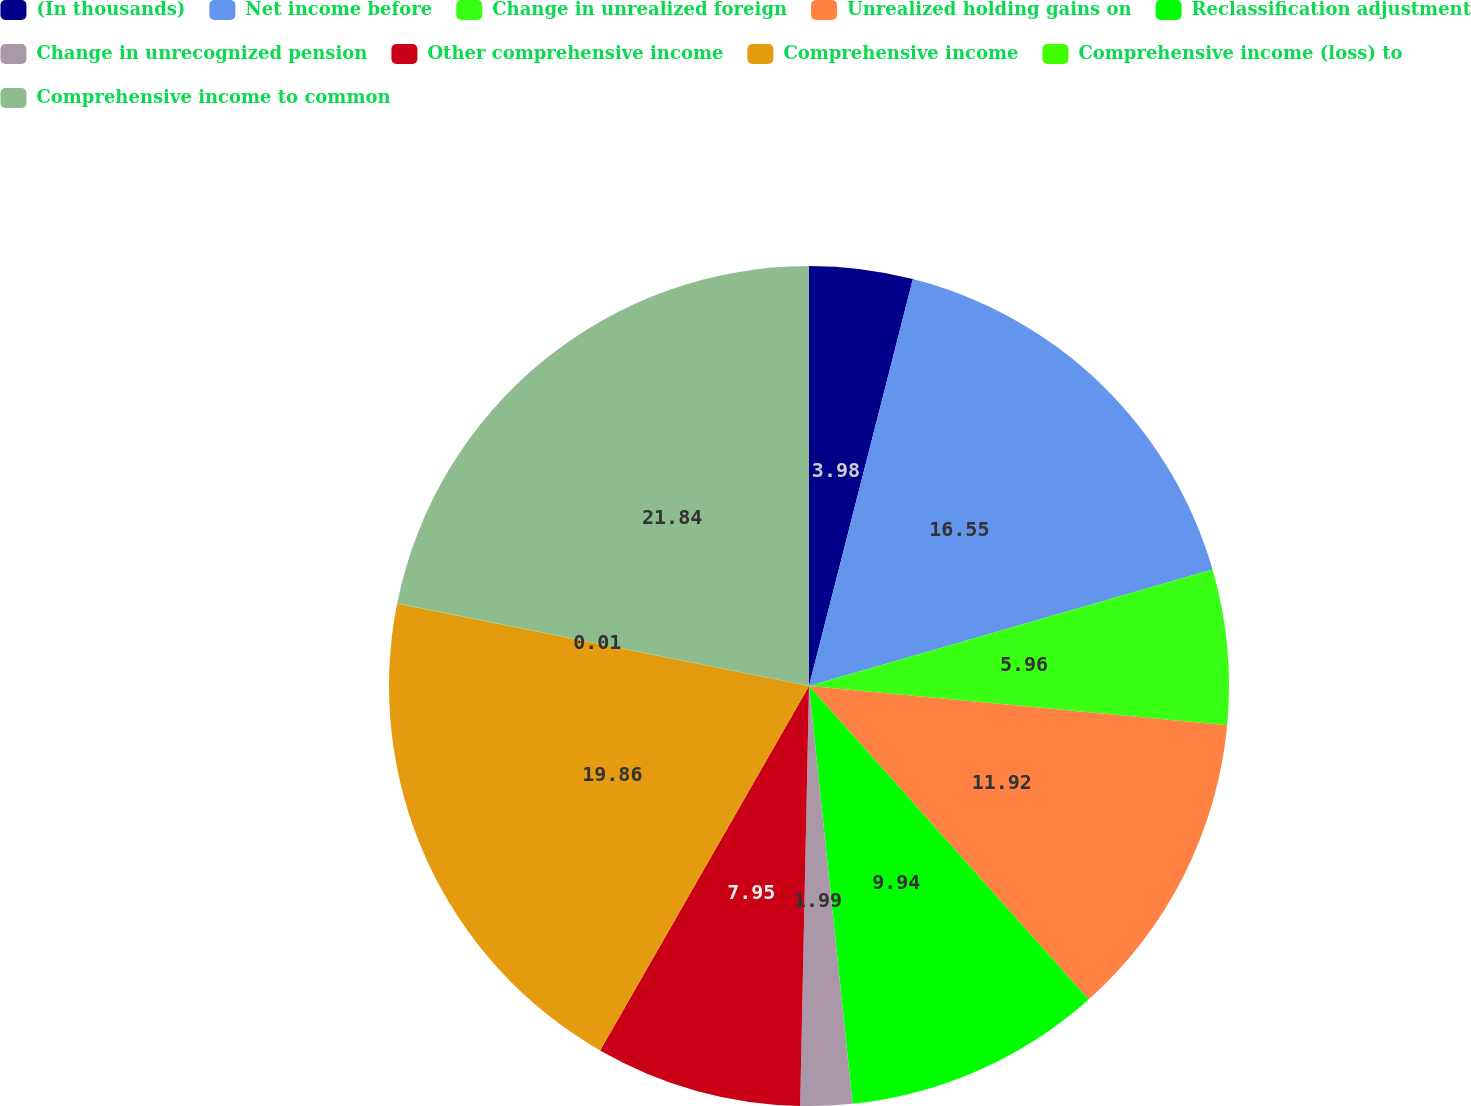Convert chart to OTSL. <chart><loc_0><loc_0><loc_500><loc_500><pie_chart><fcel>(In thousands)<fcel>Net income before<fcel>Change in unrealized foreign<fcel>Unrealized holding gains on<fcel>Reclassification adjustment<fcel>Change in unrecognized pension<fcel>Other comprehensive income<fcel>Comprehensive income<fcel>Comprehensive income (loss) to<fcel>Comprehensive income to common<nl><fcel>3.98%<fcel>16.55%<fcel>5.96%<fcel>11.92%<fcel>9.94%<fcel>1.99%<fcel>7.95%<fcel>19.86%<fcel>0.01%<fcel>21.85%<nl></chart> 